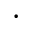Convert formula to latex. <formula><loc_0><loc_0><loc_500><loc_500>\cdot</formula> 